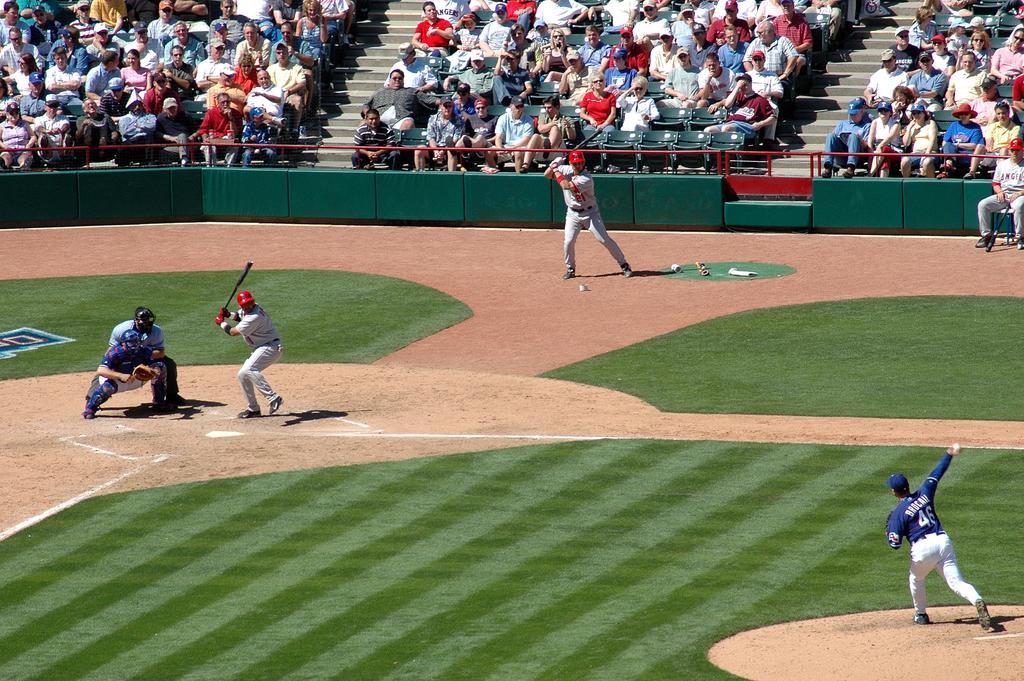Can you describe this image briefly? Here, we can see a ground, there are some people playing a game, in the background there are some people sitting on the chairs and they are watching the game. 